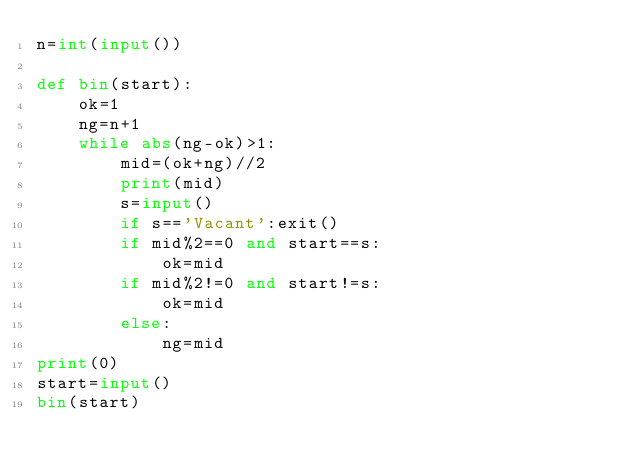<code> <loc_0><loc_0><loc_500><loc_500><_Python_>n=int(input())

def bin(start):
    ok=1
    ng=n+1
    while abs(ng-ok)>1:
        mid=(ok+ng)//2
        print(mid)
        s=input()
        if s=='Vacant':exit()
        if mid%2==0 and start==s:
            ok=mid
        if mid%2!=0 and start!=s:
            ok=mid
        else:
            ng=mid
print(0)
start=input()
bin(start)
</code> 